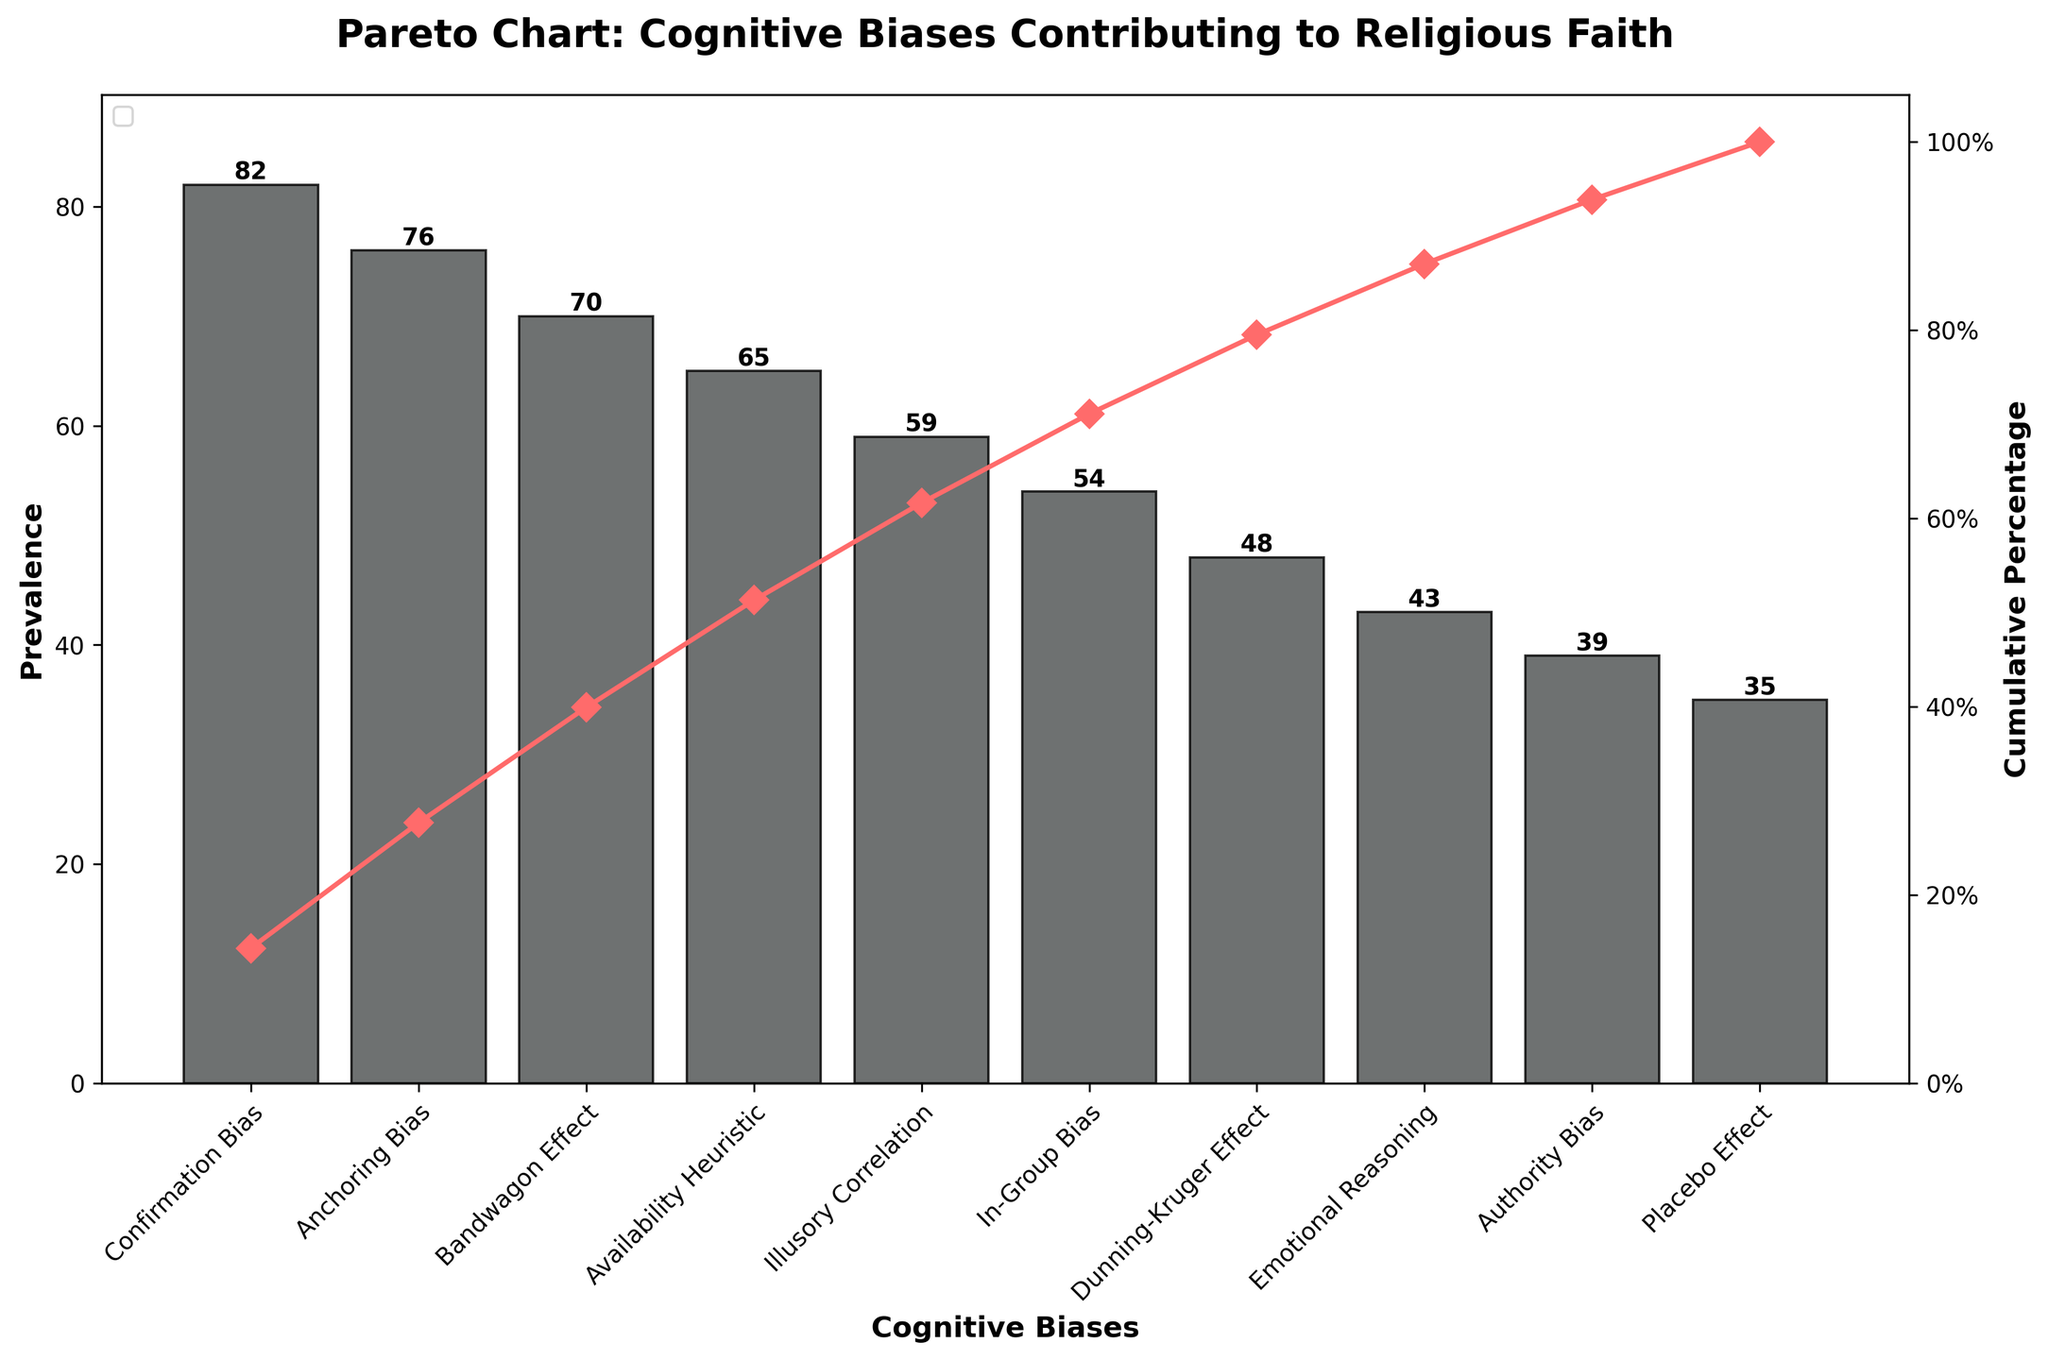What's the title of the plot? The title is displayed at the top of the figure, which summarizes what the chart represents. By reading it, we can understand the context of the data presented.
Answer: Pareto Chart: Cognitive Biases Contributing to Religious Faith What is the most prevalent cognitive bias contributing to religious faith? To find the most prevalent cognitive bias, look for the tallest bar on the plot, as the height represents the prevalence.
Answer: Confirmation Bias What's the total number of cognitive biases listed in the chart? Count the number of distinct bars along the x-axis, each representing a different cognitive bias.
Answer: 10 What cognitive bias has a prevalence of 48? Identify the bar that reaches the height corresponding to 48 on the y-axis, then check the cognitive bias labeled along the x-axis.
Answer: Dunning-Kruger Effect Which cognitive bias contributes 65 to the prevalence? Find the bar that reaches up to 65 on the y-axis and read the label on the x-axis to determine the corresponding cognitive bias.
Answer: Availability Heuristic What is the cumulative percentage at the fifth cognitive bias? Look at the line plot representing cumulative percentage and find its value above the fifth cognitive bias (Illusory Correlation).
Answer: 70% How much more prevalent is Confirmation Bias compared to Placebo Effect? Subtract the prevalence value of Placebo Effect from that of Confirmation Bias (82 - 35).
Answer: 47 Which cognitive bias lies at the median position of the dataset? With 10 cognitive biases listed, the median would be between the 5th and 6th bars. Count and identify these bars.
Answer: In-Group Bias What’s the cumulative percentage after the inclusion of the fourth cognitive bias? Identify the cumulative percentage label on the line graph after the fourth bar (Availability Heuristic).
Answer: 73% What is the difference in cumulative percentage between Confirmation Bias and Bandwagon Effect? Find the cumulative percentages at Confirmation Bias and Bandwagon Effect, then subtract the latter from the former (37% - 15%).
Answer: 22% 